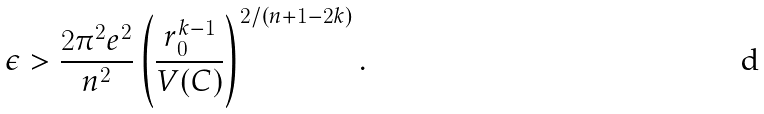Convert formula to latex. <formula><loc_0><loc_0><loc_500><loc_500>\epsilon > \frac { 2 \pi ^ { 2 } e ^ { 2 } } { n ^ { 2 } } \left ( \frac { r _ { 0 } ^ { k - 1 } } { V ( C ) } \right ) ^ { 2 / ( n + 1 - 2 k ) } .</formula> 